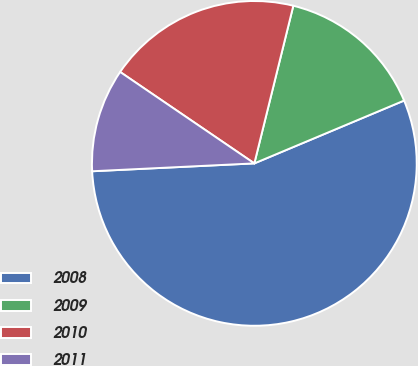Convert chart. <chart><loc_0><loc_0><loc_500><loc_500><pie_chart><fcel>2008<fcel>2009<fcel>2010<fcel>2011<nl><fcel>55.55%<fcel>14.82%<fcel>19.34%<fcel>10.29%<nl></chart> 